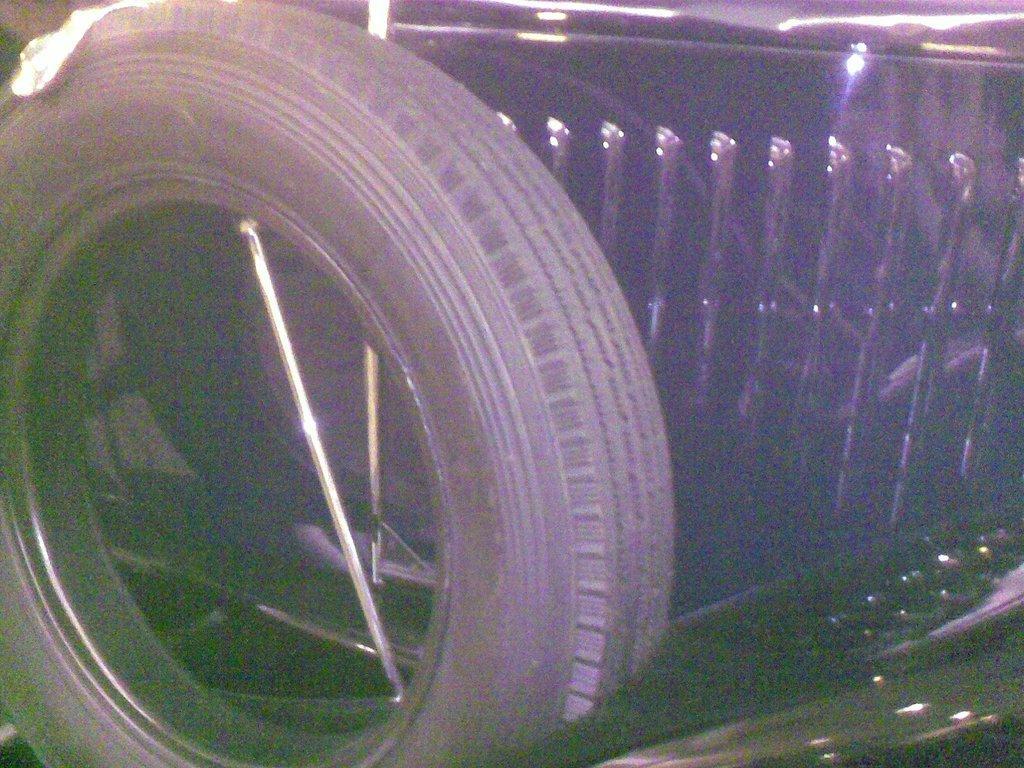Can you describe this image briefly? In the image we can see there is a vehicle kept on the ground. There is an iron rod which is kept in between the tyre. 